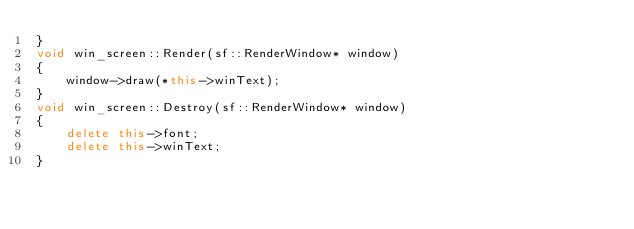<code> <loc_0><loc_0><loc_500><loc_500><_C++_>}
void win_screen::Render(sf::RenderWindow* window)
{
	window->draw(*this->winText);
}
void win_screen::Destroy(sf::RenderWindow* window)
{
	delete this->font;
	delete this->winText;
}
</code> 